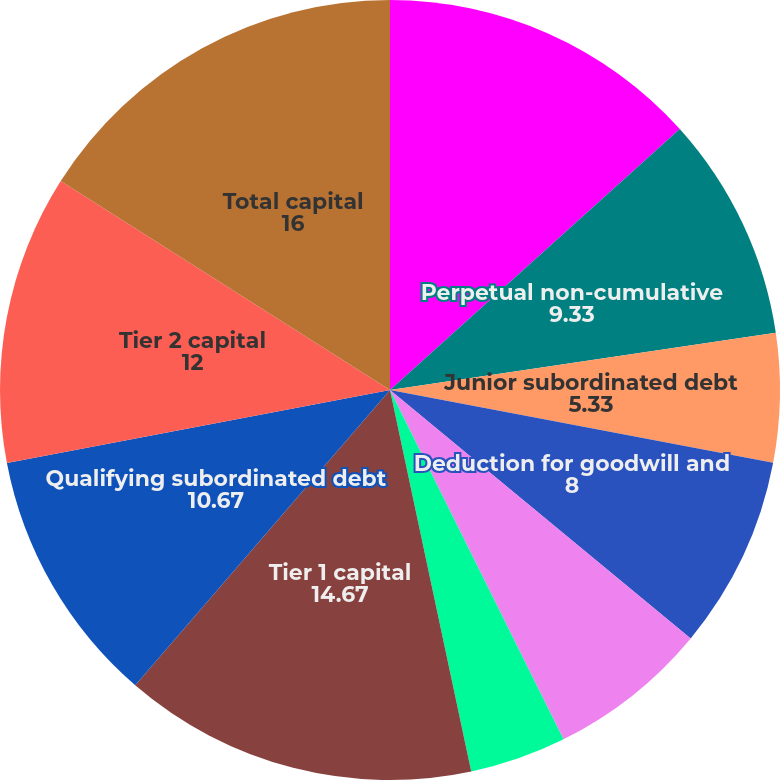Convert chart. <chart><loc_0><loc_0><loc_500><loc_500><pie_chart><fcel>Common shareholders' equity<fcel>Perpetual non-cumulative<fcel>Junior subordinated debt<fcel>Deduction for goodwill and<fcel>Deduction for equity<fcel>Other adjustments<fcel>Tier 1 capital<fcel>Qualifying subordinated debt<fcel>Tier 2 capital<fcel>Total capital<nl><fcel>13.33%<fcel>9.33%<fcel>5.33%<fcel>8.0%<fcel>6.67%<fcel>4.0%<fcel>14.67%<fcel>10.67%<fcel>12.0%<fcel>16.0%<nl></chart> 